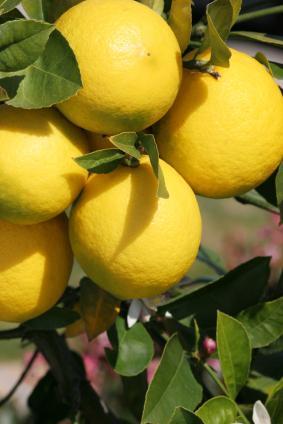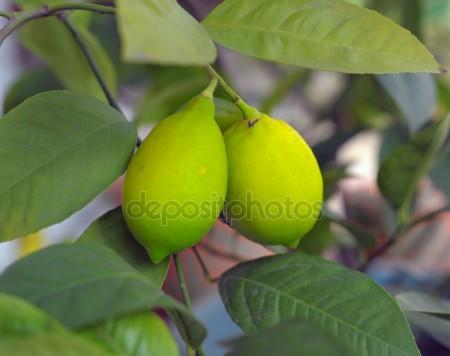The first image is the image on the left, the second image is the image on the right. Given the left and right images, does the statement "All of the lemons are connected to the same branch" hold true? Answer yes or no. Yes. The first image is the image on the left, the second image is the image on the right. Examine the images to the left and right. Is the description "Each image contains exactly two whole lemons, and the lefthand image shows lemons joined with a piece of branch and leaves intact, sitting on a surface." accurate? Answer yes or no. No. 